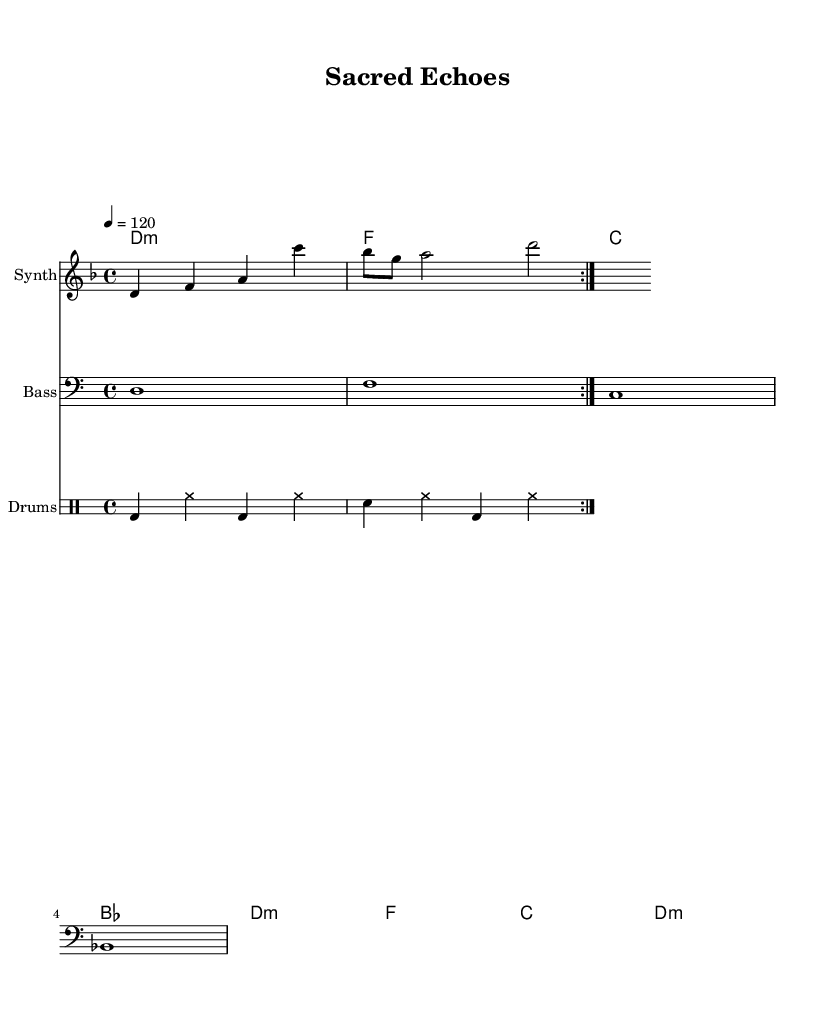What is the key signature of this music? The key signature is indicated at the beginning of the piece, where it shows one flat. This signifies that the music is in D minor, as the key signature determines the notes that will be sharpened or flattened throughout the piece.
Answer: D minor What is the time signature of this music? The time signature, found at the beginning of the music, is expressed as a fraction showing 4 beats in a measure, defined by the numerator and the denominator. This indicates that there are four quarter note beats per measure, which is standard in many dance music forms.
Answer: 4/4 What is the tempo marking of this piece? The tempo marking is specified in terms of beats per minute, located at the start of the music. It indicates that each quarter note should be played at a speed of 120 beats per minute, which provides a consistent and lively pace appropriate for dance music.
Answer: 120 Which instrument is indicated for the melody? The instrument for the melody is specified on the staff where the melodic notes are notated. In this score, the instrument is labeled as "Synth," which signifies that the melodic line will be played on a synthesizer, typical for atmospheric dance music.
Answer: Synth How many measures are in the melody? To count the measures in the melody, I look at the placement of the bar lines that segment the melodic notes into distinct measures. Each group of notes between two vertical lines represents one measure, and in this case, I can see a total of four measures in the melody.
Answer: 4 What type of harmony is used in this piece? The harmony is presented in a chord mode, where specific chords are outlined. In the score, the use of minor chords like D minor, F, and B flat chords indicates a harmonic structure that aligns with the atmospheric feel of dance music, evoking deeper emotions through its chord choices.
Answer: Minor What is the primary bass note in this music? The bass notes are notated in a specific clef indicated at the beginning of the bass staff. Looking at the bass line, the first note is D which serves as the tonal foundation for the piece, recurring through the bass segment.
Answer: D 